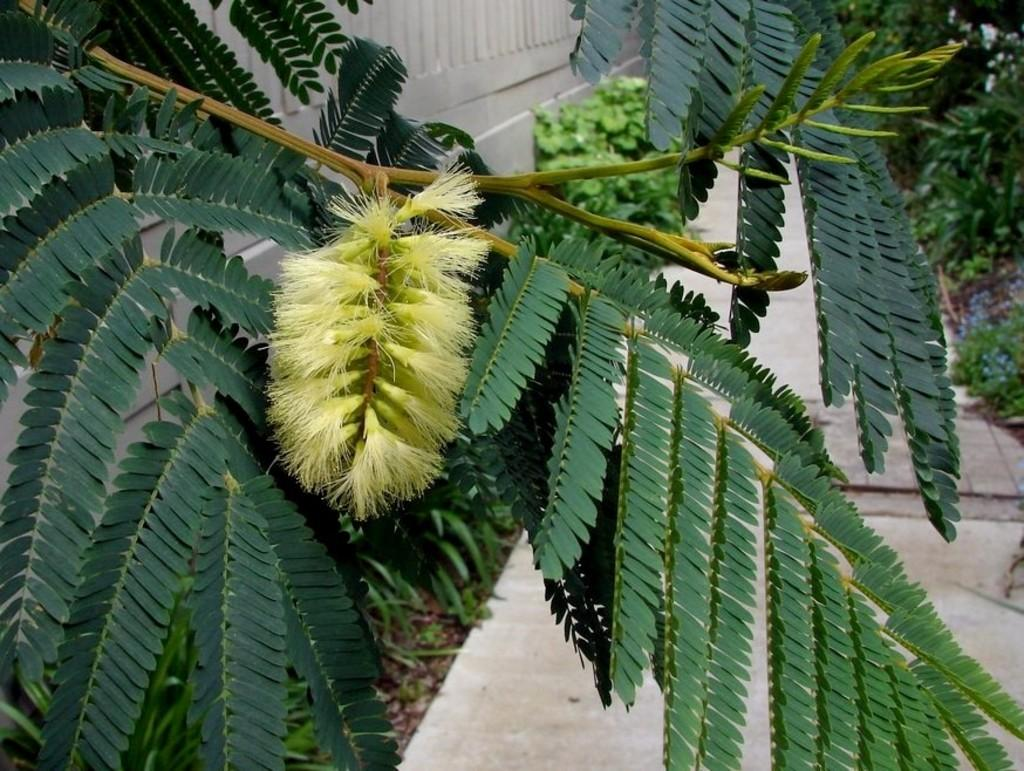What type of natural elements are present in the image? There are trees and plants in the image. What can be seen on the right side of the image? There is a path on the right side of the image. What is located on the left side of the image? There is a railing on the left side of the image. What type of chair can be seen in the image? There is no chair present in the image. What game is being played in the image? There is no game being played in the image. 